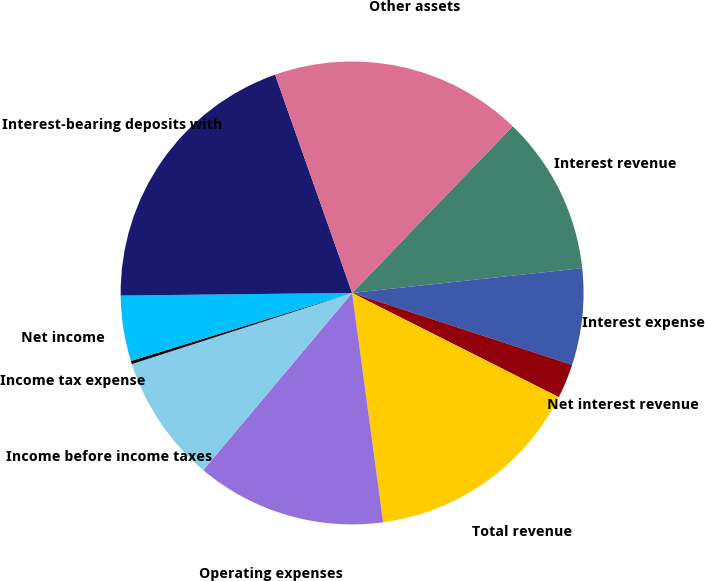Convert chart. <chart><loc_0><loc_0><loc_500><loc_500><pie_chart><fcel>Interest revenue<fcel>Interest expense<fcel>Net interest revenue<fcel>Total revenue<fcel>Operating expenses<fcel>Income before income taxes<fcel>Income tax expense<fcel>Net income<fcel>Interest-bearing deposits with<fcel>Other assets<nl><fcel>11.09%<fcel>6.74%<fcel>2.4%<fcel>15.43%<fcel>13.26%<fcel>8.91%<fcel>0.22%<fcel>4.57%<fcel>19.78%<fcel>17.6%<nl></chart> 